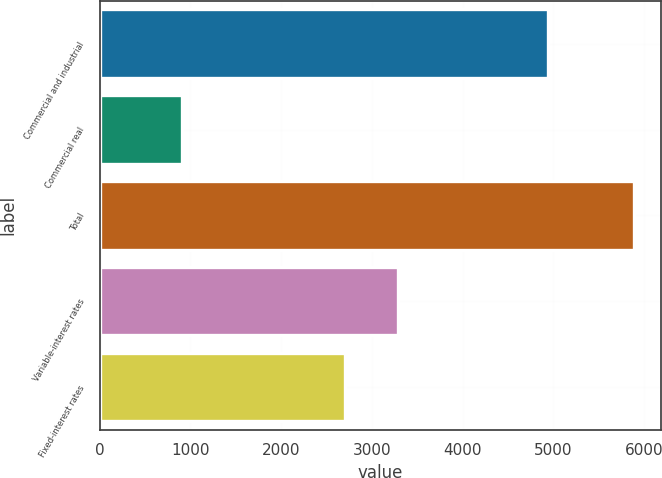Convert chart to OTSL. <chart><loc_0><loc_0><loc_500><loc_500><bar_chart><fcel>Commercial and industrial<fcel>Commercial real<fcel>Total<fcel>Variable-interest rates<fcel>Fixed-interest rates<nl><fcel>4944<fcel>908<fcel>5887<fcel>3286.2<fcel>2701<nl></chart> 